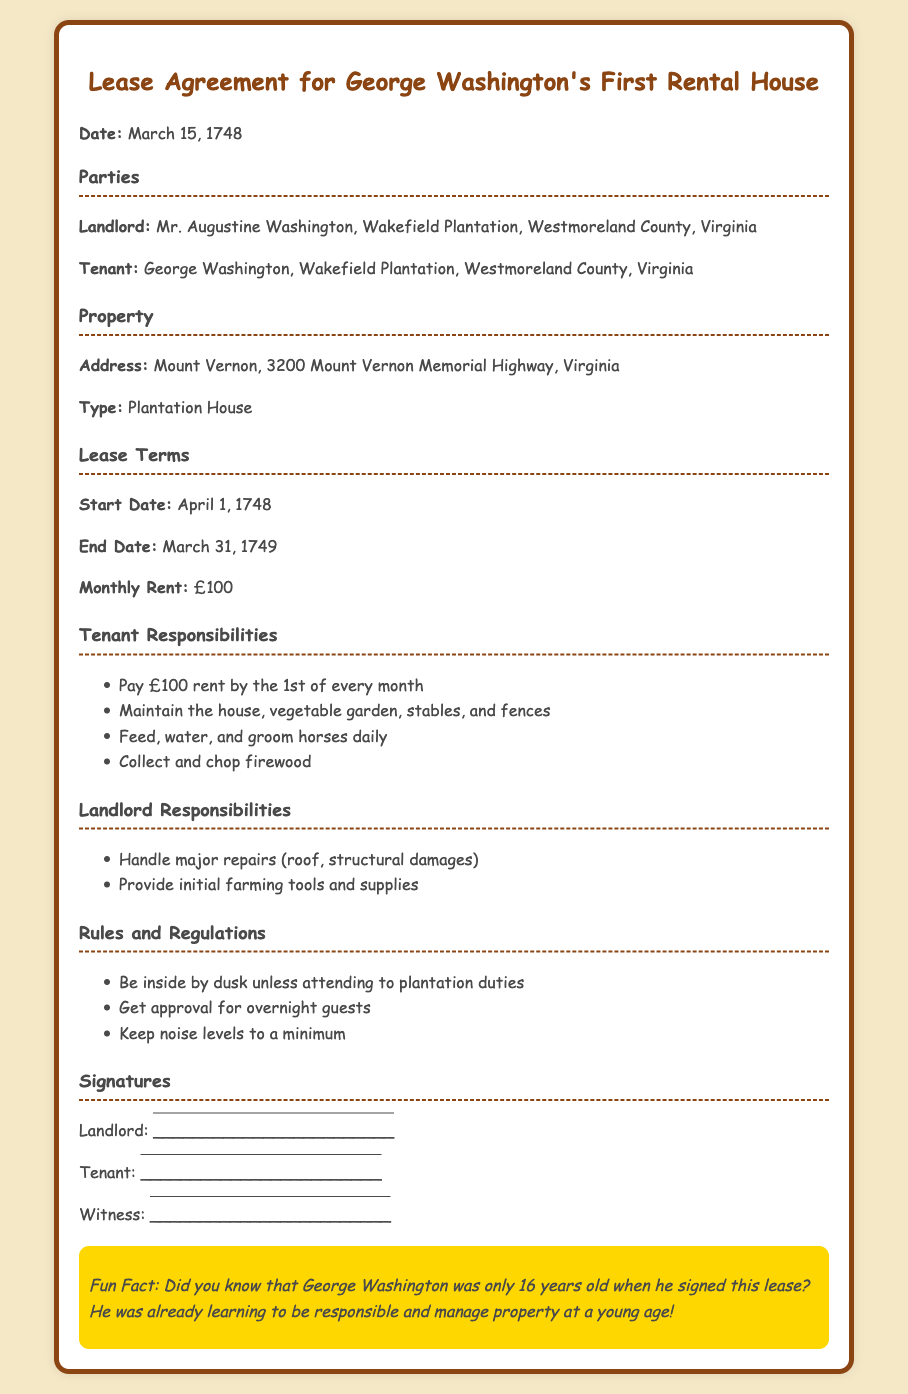What is the start date of the lease? The start date is clearly stated in the lease terms section of the document.
Answer: April 1, 1748 Who is the landlord? The landlord's name is mentioned in the parties section of the document.
Answer: Mr. Augustine Washington What is the monthly rent? The monthly rent is specified in the lease terms section.
Answer: £100 What is the address of the property? The address of the property is listed in the property section.
Answer: 3200 Mount Vernon Memorial Highway, Virginia How long is the lease term? The lease term is determined by the start and end date provided in the lease terms section.
Answer: 12 months What must the tenant do by the 1st of every month? The specific tenant responsibility is outlined in the tenant responsibilities section.
Answer: Pay £100 rent What are the major repairs the landlord is responsible for? This information is found in the landlord responsibilities section of the document.
Answer: Roof, structural damages What must the tenants do with the horses? This responsibility is mentioned in the tenant responsibilities section.
Answer: Feed, water, and groom daily What should tenants get approval for? This requirement is included in the rules and regulations section of the document.
Answer: Overnight guests 